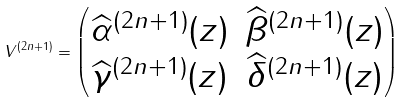Convert formula to latex. <formula><loc_0><loc_0><loc_500><loc_500>V ^ { ( 2 n + 1 ) } = \begin{pmatrix} \widehat { \alpha } ^ { ( 2 n + 1 ) } ( z ) & \widehat { \beta } ^ { ( 2 n + 1 ) } ( z ) \\ \widehat { \gamma } ^ { ( 2 n + 1 ) } ( z ) & \widehat { \delta } ^ { ( 2 n + 1 ) } ( z ) \end{pmatrix}</formula> 